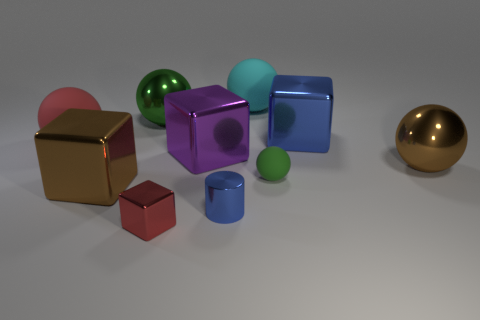Do the cyan ball and the green object that is behind the large blue metal block have the same material?
Give a very brief answer. No. What number of things are either shiny blocks on the left side of the tiny green thing or big red rubber balls?
Give a very brief answer. 4. Are there any other metallic spheres that have the same color as the small sphere?
Ensure brevity in your answer.  Yes. Does the small red metal object have the same shape as the large rubber object that is in front of the cyan matte ball?
Provide a succinct answer. No. What number of big shiny objects are in front of the green metallic sphere and behind the large red rubber ball?
Ensure brevity in your answer.  1. There is a brown thing that is the same shape as the big blue metal thing; what is its material?
Keep it short and to the point. Metal. How big is the blue metal thing left of the small thing on the right side of the cyan rubber ball?
Offer a very short reply. Small. Are there any large blue metal cubes?
Keep it short and to the point. Yes. There is a ball that is both behind the large red thing and on the right side of the red cube; what is its material?
Your response must be concise. Rubber. Are there more big red matte objects behind the tiny green matte sphere than big red spheres on the right side of the small blue metal thing?
Make the answer very short. Yes. 